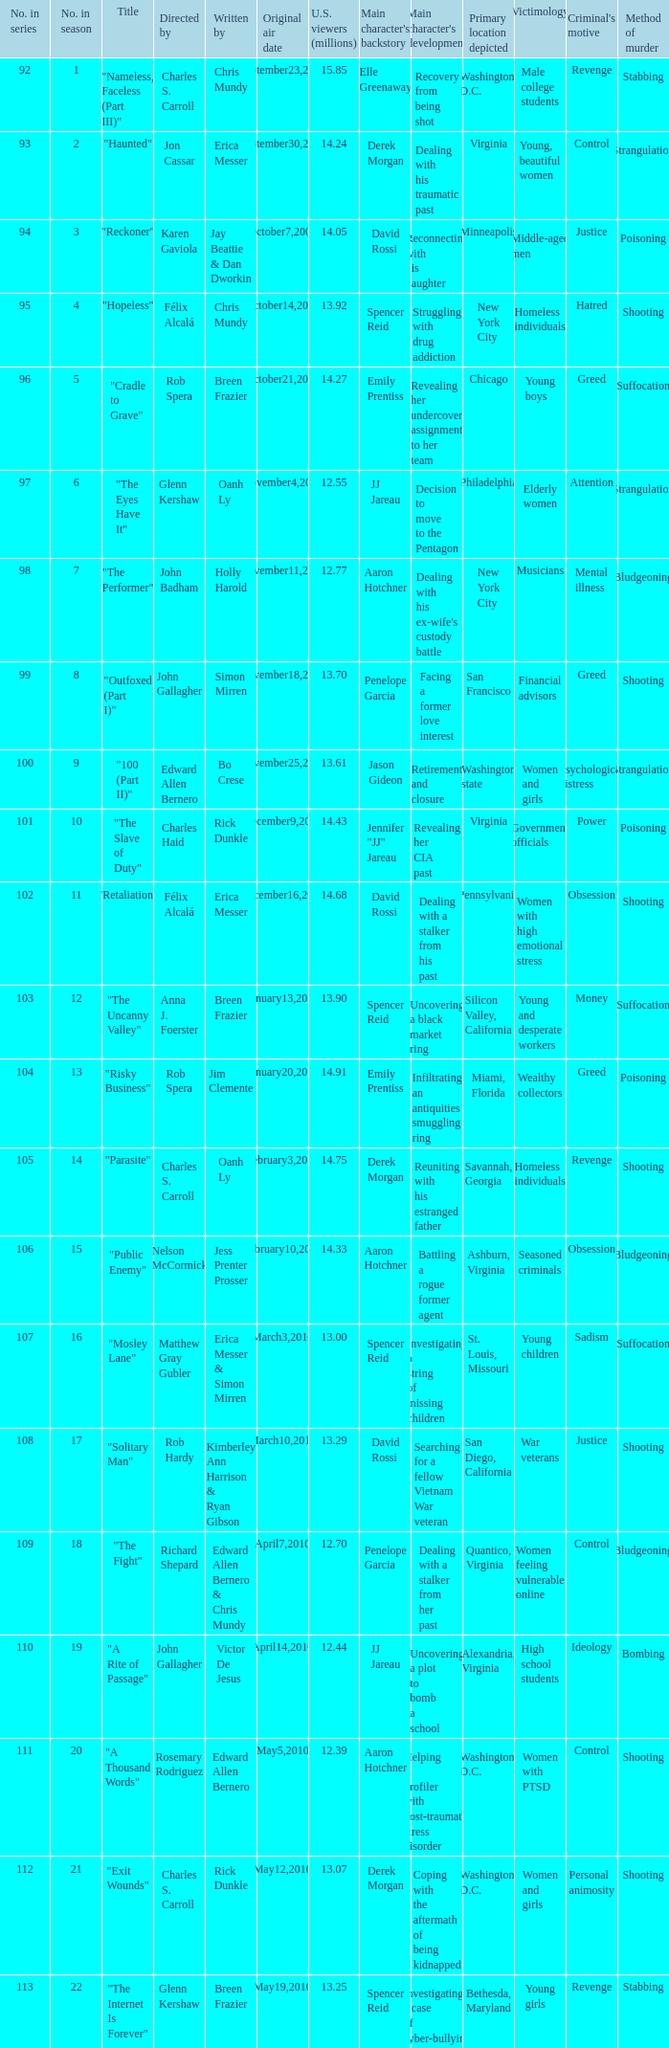92 million us viewers? October14,2009. 